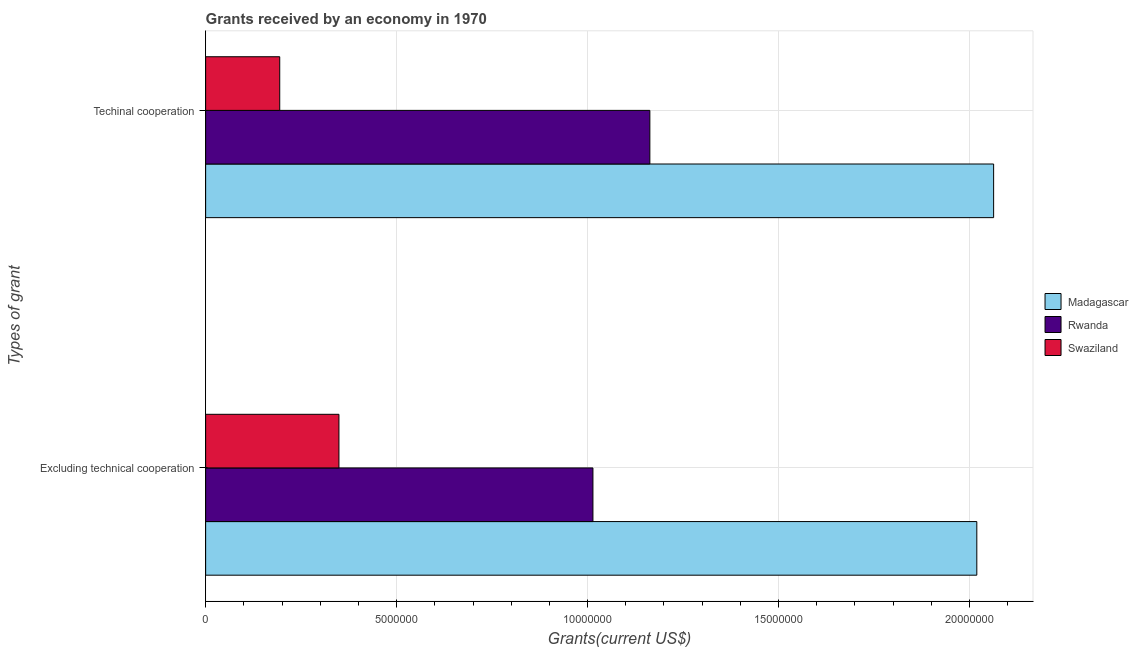Are the number of bars on each tick of the Y-axis equal?
Provide a succinct answer. Yes. How many bars are there on the 2nd tick from the bottom?
Offer a very short reply. 3. What is the label of the 2nd group of bars from the top?
Offer a terse response. Excluding technical cooperation. What is the amount of grants received(including technical cooperation) in Rwanda?
Keep it short and to the point. 1.16e+07. Across all countries, what is the maximum amount of grants received(including technical cooperation)?
Provide a short and direct response. 2.06e+07. Across all countries, what is the minimum amount of grants received(including technical cooperation)?
Provide a succinct answer. 1.94e+06. In which country was the amount of grants received(excluding technical cooperation) maximum?
Make the answer very short. Madagascar. In which country was the amount of grants received(including technical cooperation) minimum?
Your answer should be compact. Swaziland. What is the total amount of grants received(excluding technical cooperation) in the graph?
Your response must be concise. 3.38e+07. What is the difference between the amount of grants received(including technical cooperation) in Madagascar and that in Swaziland?
Offer a terse response. 1.87e+07. What is the difference between the amount of grants received(including technical cooperation) in Madagascar and the amount of grants received(excluding technical cooperation) in Rwanda?
Keep it short and to the point. 1.05e+07. What is the average amount of grants received(including technical cooperation) per country?
Your answer should be compact. 1.14e+07. What is the difference between the amount of grants received(including technical cooperation) and amount of grants received(excluding technical cooperation) in Madagascar?
Keep it short and to the point. 4.40e+05. What is the ratio of the amount of grants received(including technical cooperation) in Rwanda to that in Madagascar?
Your answer should be compact. 0.56. Is the amount of grants received(excluding technical cooperation) in Rwanda less than that in Swaziland?
Offer a terse response. No. In how many countries, is the amount of grants received(including technical cooperation) greater than the average amount of grants received(including technical cooperation) taken over all countries?
Your answer should be very brief. 2. What does the 1st bar from the top in Excluding technical cooperation represents?
Give a very brief answer. Swaziland. What does the 1st bar from the bottom in Excluding technical cooperation represents?
Provide a succinct answer. Madagascar. Are all the bars in the graph horizontal?
Provide a short and direct response. Yes. How many countries are there in the graph?
Give a very brief answer. 3. What is the difference between two consecutive major ticks on the X-axis?
Offer a terse response. 5.00e+06. Does the graph contain grids?
Provide a succinct answer. Yes. Where does the legend appear in the graph?
Keep it short and to the point. Center right. How many legend labels are there?
Make the answer very short. 3. What is the title of the graph?
Your answer should be compact. Grants received by an economy in 1970. What is the label or title of the X-axis?
Your answer should be very brief. Grants(current US$). What is the label or title of the Y-axis?
Keep it short and to the point. Types of grant. What is the Grants(current US$) in Madagascar in Excluding technical cooperation?
Offer a very short reply. 2.02e+07. What is the Grants(current US$) in Rwanda in Excluding technical cooperation?
Offer a terse response. 1.01e+07. What is the Grants(current US$) in Swaziland in Excluding technical cooperation?
Give a very brief answer. 3.49e+06. What is the Grants(current US$) of Madagascar in Techinal cooperation?
Provide a succinct answer. 2.06e+07. What is the Grants(current US$) in Rwanda in Techinal cooperation?
Give a very brief answer. 1.16e+07. What is the Grants(current US$) in Swaziland in Techinal cooperation?
Your answer should be compact. 1.94e+06. Across all Types of grant, what is the maximum Grants(current US$) of Madagascar?
Your answer should be very brief. 2.06e+07. Across all Types of grant, what is the maximum Grants(current US$) of Rwanda?
Your answer should be compact. 1.16e+07. Across all Types of grant, what is the maximum Grants(current US$) of Swaziland?
Your answer should be compact. 3.49e+06. Across all Types of grant, what is the minimum Grants(current US$) of Madagascar?
Offer a very short reply. 2.02e+07. Across all Types of grant, what is the minimum Grants(current US$) of Rwanda?
Provide a succinct answer. 1.01e+07. Across all Types of grant, what is the minimum Grants(current US$) of Swaziland?
Provide a succinct answer. 1.94e+06. What is the total Grants(current US$) of Madagascar in the graph?
Your answer should be very brief. 4.08e+07. What is the total Grants(current US$) of Rwanda in the graph?
Your response must be concise. 2.18e+07. What is the total Grants(current US$) in Swaziland in the graph?
Keep it short and to the point. 5.43e+06. What is the difference between the Grants(current US$) of Madagascar in Excluding technical cooperation and that in Techinal cooperation?
Offer a terse response. -4.40e+05. What is the difference between the Grants(current US$) in Rwanda in Excluding technical cooperation and that in Techinal cooperation?
Your answer should be compact. -1.49e+06. What is the difference between the Grants(current US$) in Swaziland in Excluding technical cooperation and that in Techinal cooperation?
Your response must be concise. 1.55e+06. What is the difference between the Grants(current US$) of Madagascar in Excluding technical cooperation and the Grants(current US$) of Rwanda in Techinal cooperation?
Give a very brief answer. 8.56e+06. What is the difference between the Grants(current US$) in Madagascar in Excluding technical cooperation and the Grants(current US$) in Swaziland in Techinal cooperation?
Provide a succinct answer. 1.82e+07. What is the difference between the Grants(current US$) in Rwanda in Excluding technical cooperation and the Grants(current US$) in Swaziland in Techinal cooperation?
Your answer should be compact. 8.20e+06. What is the average Grants(current US$) in Madagascar per Types of grant?
Provide a short and direct response. 2.04e+07. What is the average Grants(current US$) in Rwanda per Types of grant?
Offer a very short reply. 1.09e+07. What is the average Grants(current US$) of Swaziland per Types of grant?
Give a very brief answer. 2.72e+06. What is the difference between the Grants(current US$) in Madagascar and Grants(current US$) in Rwanda in Excluding technical cooperation?
Provide a short and direct response. 1.00e+07. What is the difference between the Grants(current US$) of Madagascar and Grants(current US$) of Swaziland in Excluding technical cooperation?
Offer a terse response. 1.67e+07. What is the difference between the Grants(current US$) of Rwanda and Grants(current US$) of Swaziland in Excluding technical cooperation?
Keep it short and to the point. 6.65e+06. What is the difference between the Grants(current US$) in Madagascar and Grants(current US$) in Rwanda in Techinal cooperation?
Keep it short and to the point. 9.00e+06. What is the difference between the Grants(current US$) in Madagascar and Grants(current US$) in Swaziland in Techinal cooperation?
Provide a short and direct response. 1.87e+07. What is the difference between the Grants(current US$) in Rwanda and Grants(current US$) in Swaziland in Techinal cooperation?
Provide a short and direct response. 9.69e+06. What is the ratio of the Grants(current US$) in Madagascar in Excluding technical cooperation to that in Techinal cooperation?
Provide a short and direct response. 0.98. What is the ratio of the Grants(current US$) in Rwanda in Excluding technical cooperation to that in Techinal cooperation?
Ensure brevity in your answer.  0.87. What is the ratio of the Grants(current US$) in Swaziland in Excluding technical cooperation to that in Techinal cooperation?
Ensure brevity in your answer.  1.8. What is the difference between the highest and the second highest Grants(current US$) in Rwanda?
Give a very brief answer. 1.49e+06. What is the difference between the highest and the second highest Grants(current US$) of Swaziland?
Keep it short and to the point. 1.55e+06. What is the difference between the highest and the lowest Grants(current US$) of Rwanda?
Keep it short and to the point. 1.49e+06. What is the difference between the highest and the lowest Grants(current US$) in Swaziland?
Provide a succinct answer. 1.55e+06. 